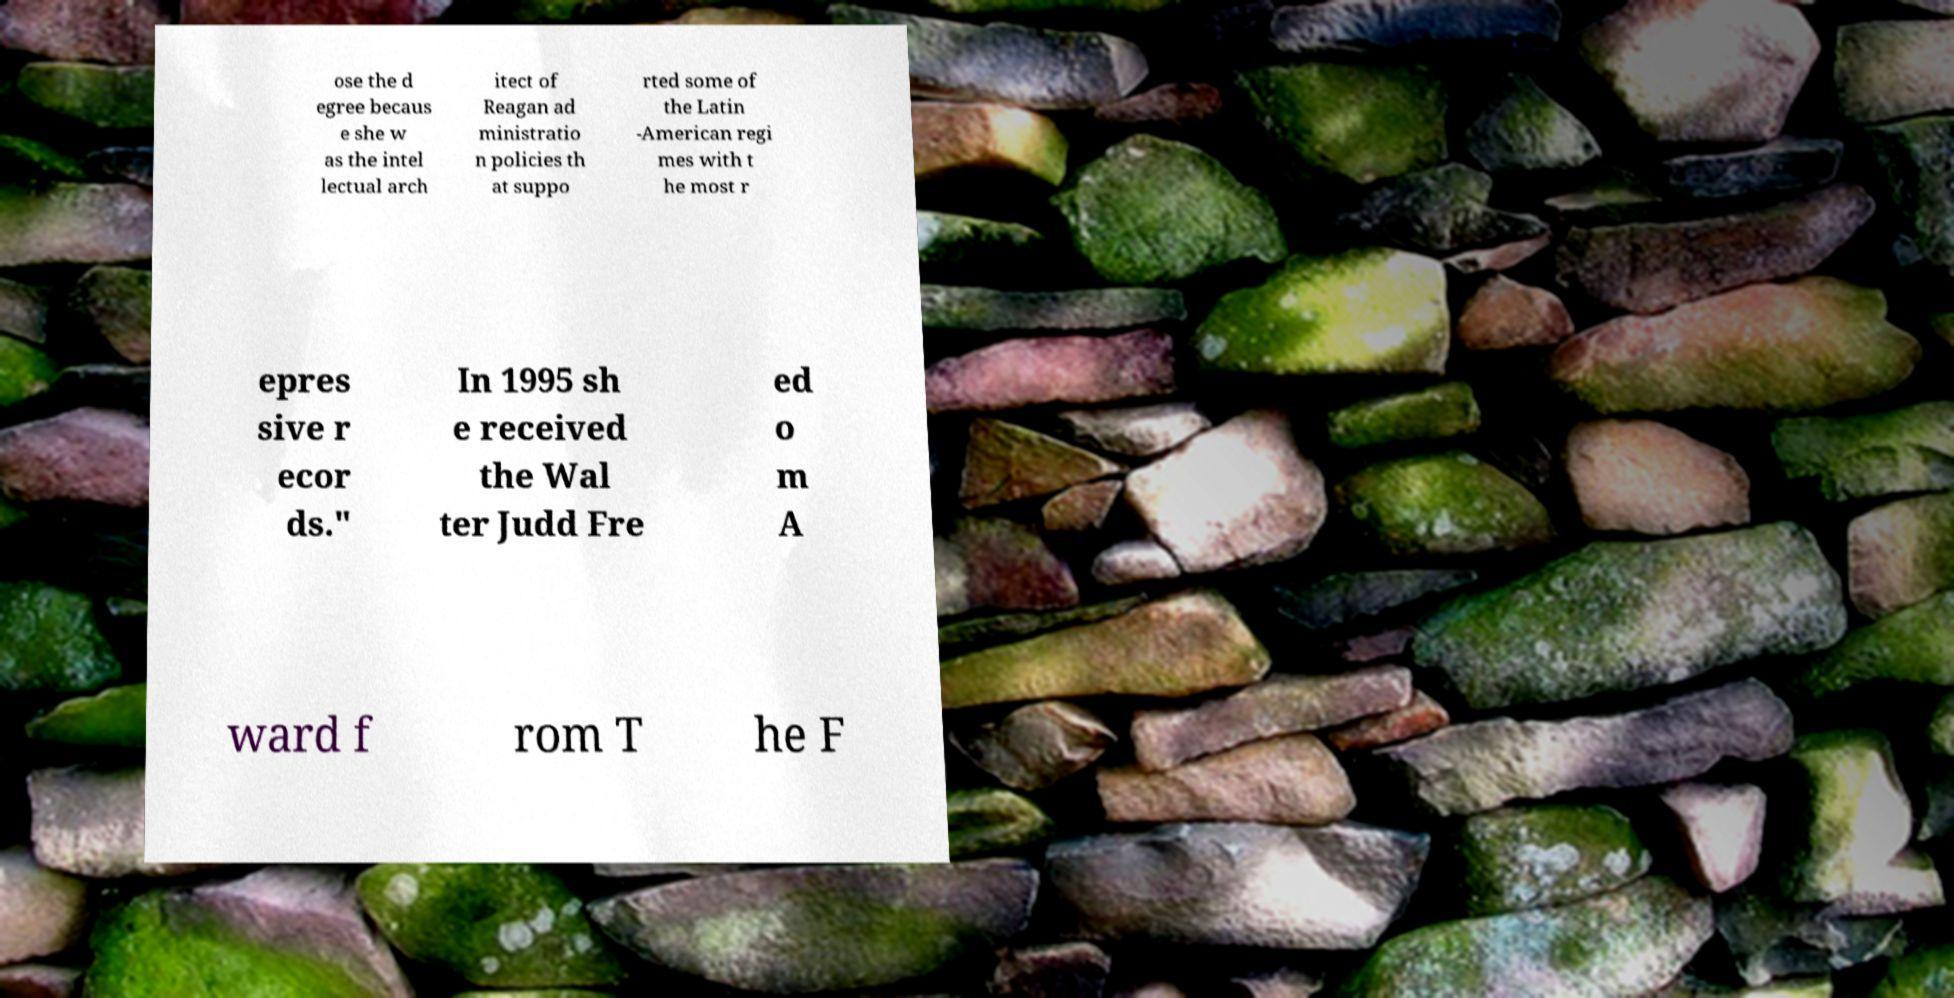Please read and relay the text visible in this image. What does it say? ose the d egree becaus e she w as the intel lectual arch itect of Reagan ad ministratio n policies th at suppo rted some of the Latin -American regi mes with t he most r epres sive r ecor ds." In 1995 sh e received the Wal ter Judd Fre ed o m A ward f rom T he F 